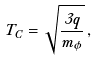<formula> <loc_0><loc_0><loc_500><loc_500>T _ { C } = \sqrt { \frac { 3 q } { m _ { \phi } } } \, ,</formula> 